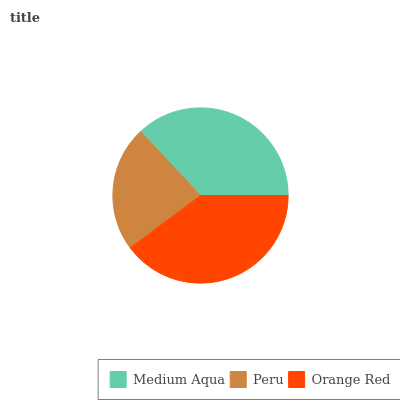Is Peru the minimum?
Answer yes or no. Yes. Is Orange Red the maximum?
Answer yes or no. Yes. Is Orange Red the minimum?
Answer yes or no. No. Is Peru the maximum?
Answer yes or no. No. Is Orange Red greater than Peru?
Answer yes or no. Yes. Is Peru less than Orange Red?
Answer yes or no. Yes. Is Peru greater than Orange Red?
Answer yes or no. No. Is Orange Red less than Peru?
Answer yes or no. No. Is Medium Aqua the high median?
Answer yes or no. Yes. Is Medium Aqua the low median?
Answer yes or no. Yes. Is Orange Red the high median?
Answer yes or no. No. Is Peru the low median?
Answer yes or no. No. 